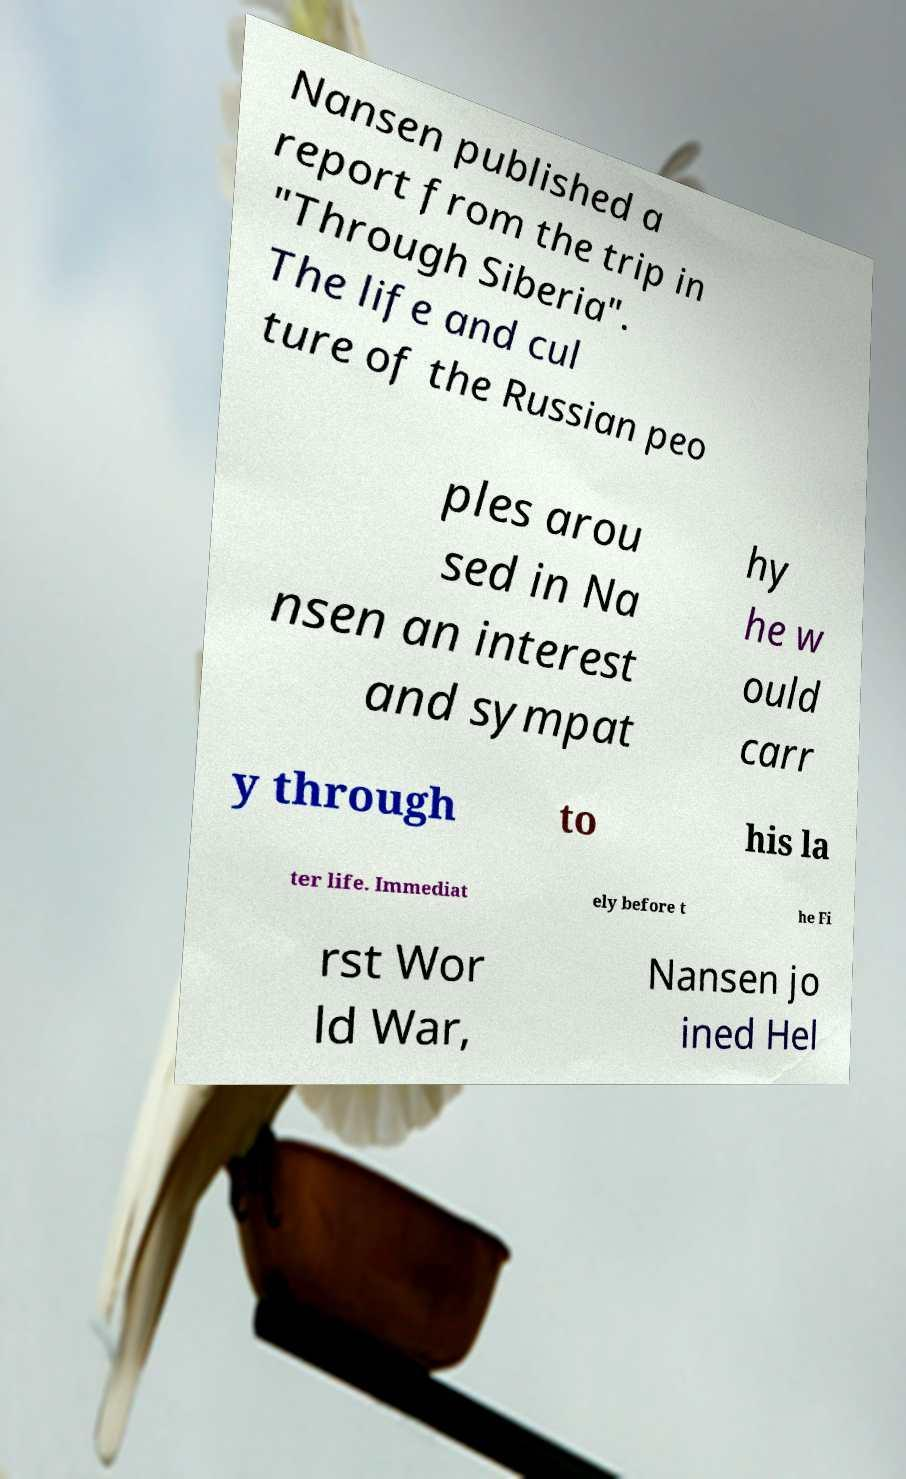Can you read and provide the text displayed in the image?This photo seems to have some interesting text. Can you extract and type it out for me? Nansen published a report from the trip in "Through Siberia". The life and cul ture of the Russian peo ples arou sed in Na nsen an interest and sympat hy he w ould carr y through to his la ter life. Immediat ely before t he Fi rst Wor ld War, Nansen jo ined Hel 